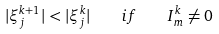Convert formula to latex. <formula><loc_0><loc_0><loc_500><loc_500>| \xi _ { j } ^ { k + 1 } | < | \xi _ { j } ^ { k } | \quad i f \quad I _ { m } ^ { k } \neq 0</formula> 